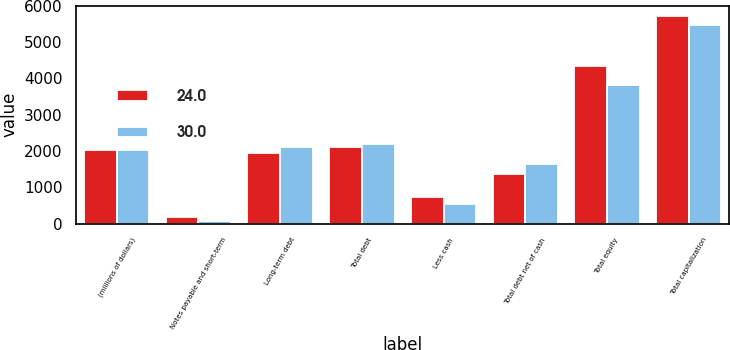<chart> <loc_0><loc_0><loc_500><loc_500><stacked_bar_chart><ecel><fcel>(millions of dollars)<fcel>Notes payable and short-term<fcel>Long-term debt<fcel>Total debt<fcel>Less cash<fcel>Total debt net of cash<fcel>Total equity<fcel>Total capitalization<nl><fcel>24<fcel>2018<fcel>172.6<fcel>1940.7<fcel>2113.3<fcel>739.4<fcel>1373.9<fcel>4344.8<fcel>5718.7<nl><fcel>30<fcel>2017<fcel>84.6<fcel>2103.7<fcel>2188.3<fcel>545.3<fcel>1643<fcel>3825.9<fcel>5468.9<nl></chart> 